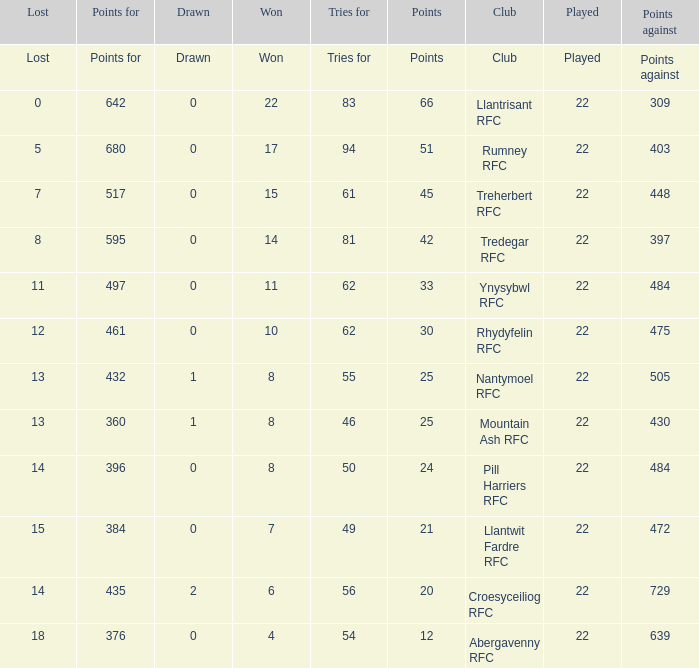How many tries for were scored by the team that had exactly 396 points for? 50.0. 